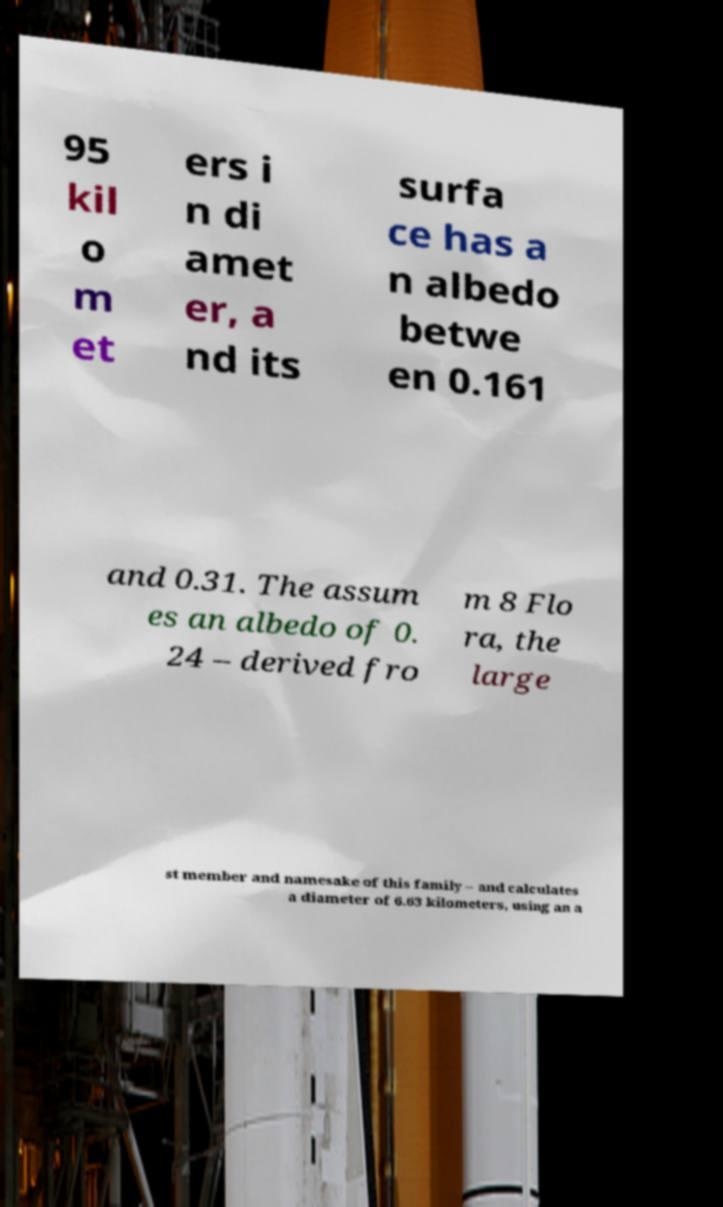Could you extract and type out the text from this image? 95 kil o m et ers i n di amet er, a nd its surfa ce has a n albedo betwe en 0.161 and 0.31. The assum es an albedo of 0. 24 – derived fro m 8 Flo ra, the large st member and namesake of this family – and calculates a diameter of 6.63 kilometers, using an a 